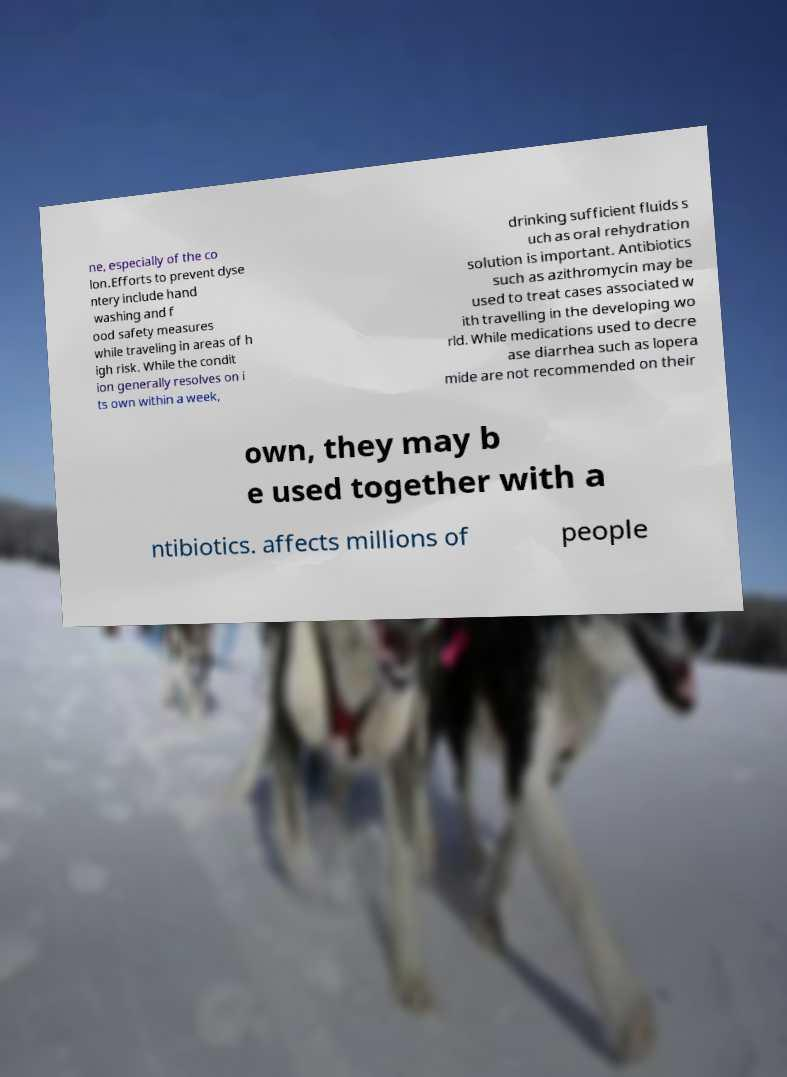Please read and relay the text visible in this image. What does it say? ne, especially of the co lon.Efforts to prevent dyse ntery include hand washing and f ood safety measures while traveling in areas of h igh risk. While the condit ion generally resolves on i ts own within a week, drinking sufficient fluids s uch as oral rehydration solution is important. Antibiotics such as azithromycin may be used to treat cases associated w ith travelling in the developing wo rld. While medications used to decre ase diarrhea such as lopera mide are not recommended on their own, they may b e used together with a ntibiotics. affects millions of people 